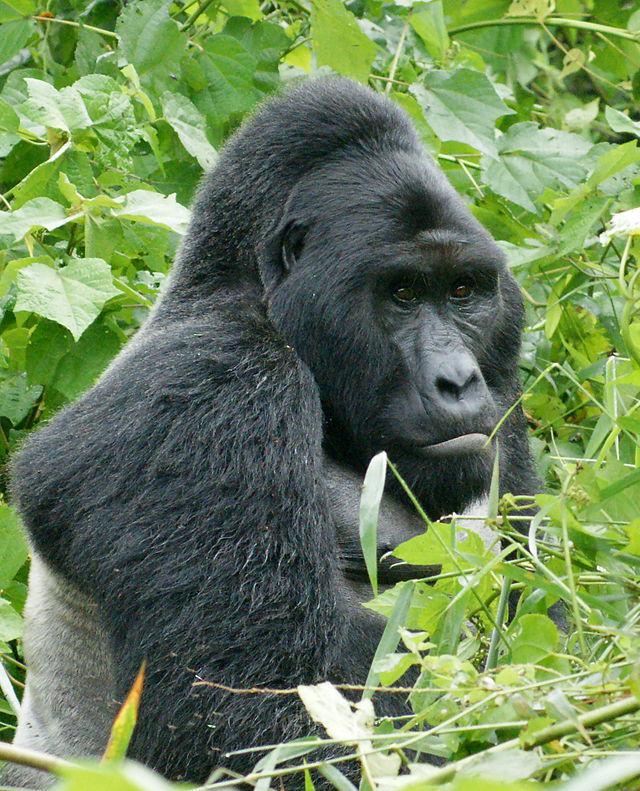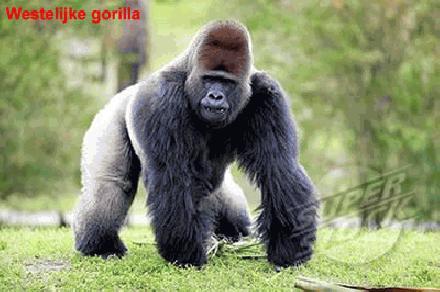The first image is the image on the left, the second image is the image on the right. Assess this claim about the two images: "All of the images only contain one gorilla.". Correct or not? Answer yes or no. Yes. The first image is the image on the left, the second image is the image on the right. Considering the images on both sides, is "There are two gorillas total." valid? Answer yes or no. Yes. 